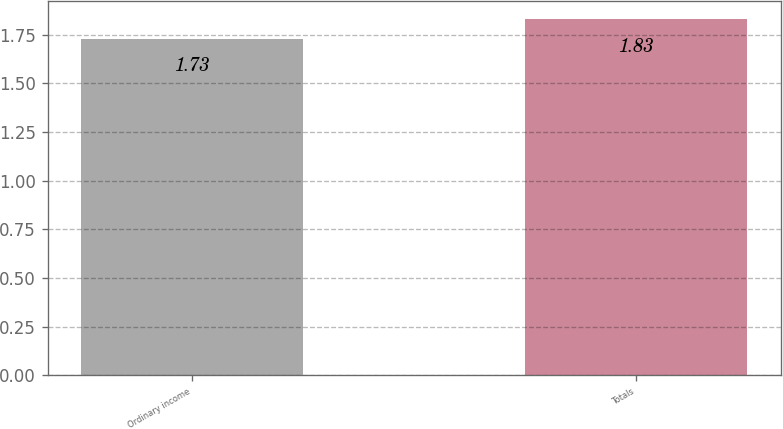<chart> <loc_0><loc_0><loc_500><loc_500><bar_chart><fcel>Ordinary income<fcel>Totals<nl><fcel>1.73<fcel>1.83<nl></chart> 